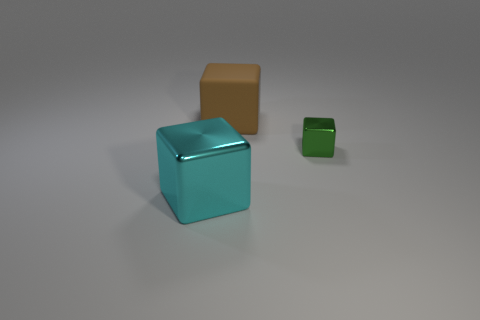What is the cube that is both behind the big metal block and left of the green shiny block made of?
Your answer should be compact. Rubber. What material is the cyan thing that is the same size as the brown thing?
Provide a succinct answer. Metal. There is a cube that is on the right side of the object that is behind the shiny cube that is to the right of the rubber block; what size is it?
Give a very brief answer. Small. What size is the cyan block that is made of the same material as the tiny thing?
Offer a terse response. Large. There is a cyan thing; does it have the same size as the rubber block that is behind the big cyan object?
Keep it short and to the point. Yes. There is a thing that is to the right of the brown matte thing; what shape is it?
Your answer should be very brief. Cube. There is a shiny cube behind the shiny block that is to the left of the rubber thing; is there a green shiny thing behind it?
Offer a very short reply. No. There is a big brown thing that is the same shape as the large cyan shiny object; what is its material?
Your response must be concise. Rubber. Are there any other things that have the same material as the big brown object?
Keep it short and to the point. No. How many spheres are either small green metal things or tiny gray rubber things?
Your response must be concise. 0. 